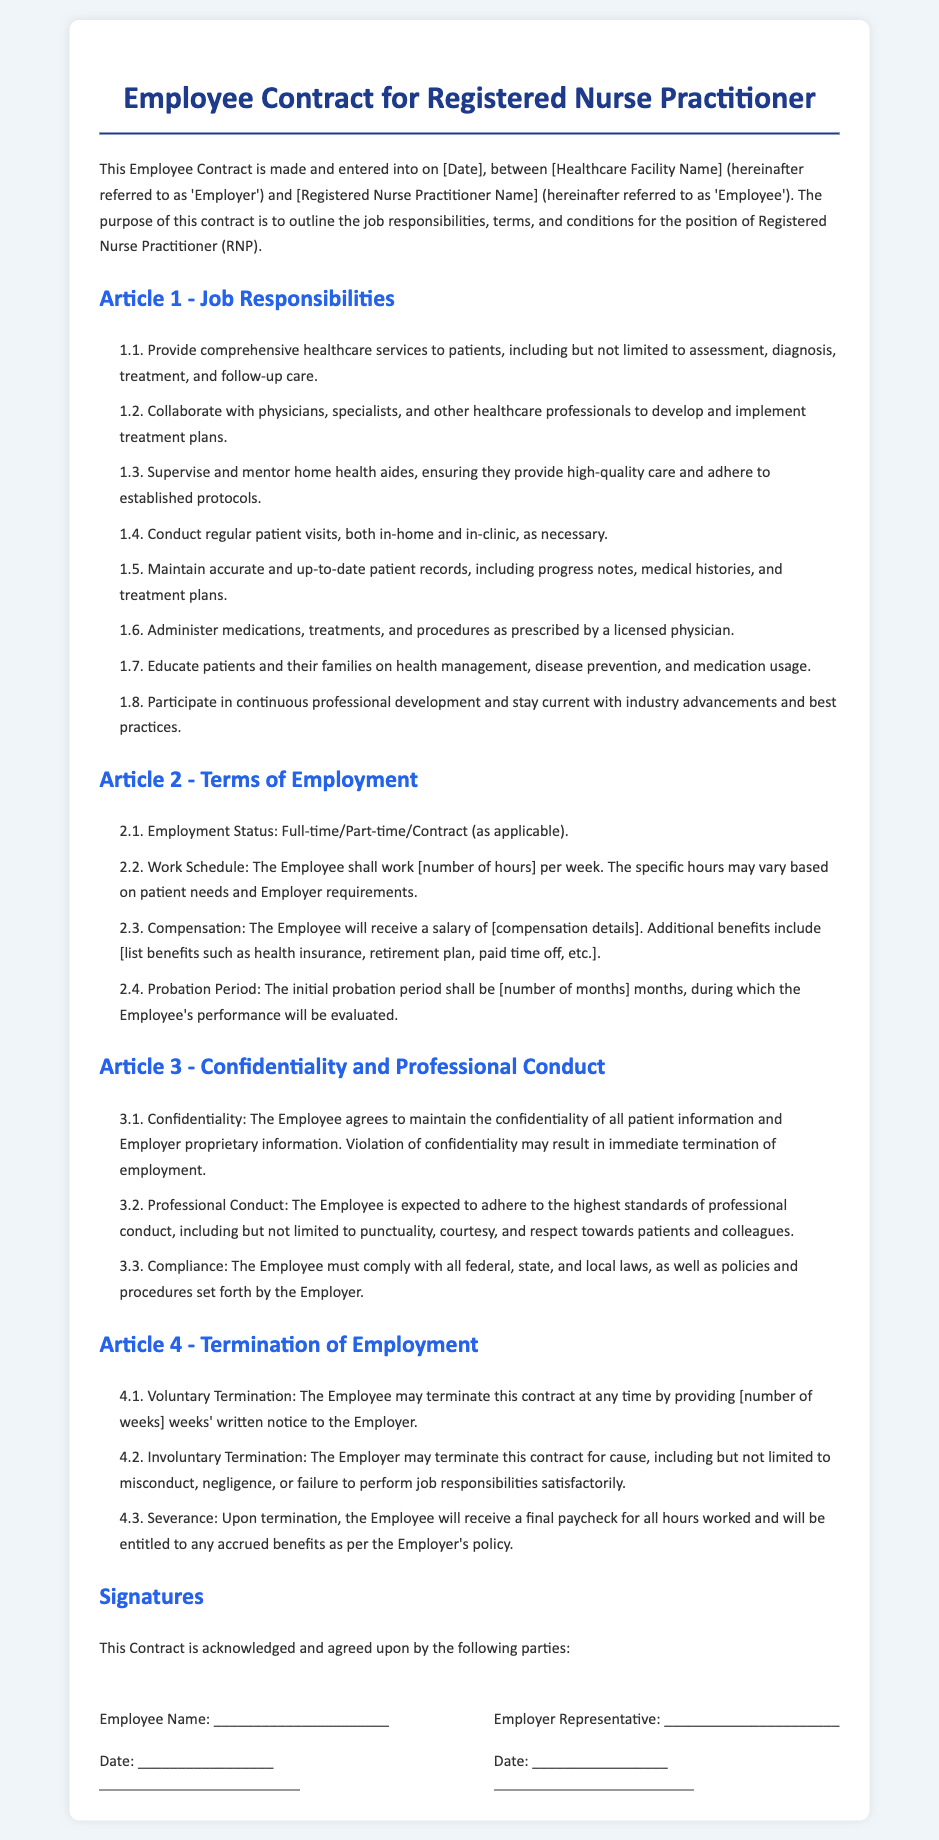What is the position title in the contract? The position title is explicitly mentioned in the document as "Registered Nurse Practitioner."
Answer: Registered Nurse Practitioner What is one of the job responsibilities of the Employee? The document lists various responsibilities, one of which is to "provide comprehensive healthcare services to patients."
Answer: Provide comprehensive healthcare services to patients How many months is the probation period? The document specifies the probation period but requires a number to be filled in; hence the answer should reflect that.
Answer: [number of months] What kind of employment status is mentioned? The document states the employment status could be "Full-time/Part-time/Contract."
Answer: Full-time/Part-time/Contract What is required for voluntary termination? The document indicates that the Employee may terminate the contract by providing a certain number of weeks' notice.
Answer: [number of weeks] What type of conduct is expected from the Employee? The contract highlights that the Employee is expected to adhere to the "highest standards of professional conduct."
Answer: Highest standards of professional conduct What should the Employee maintain regarding patient information? The document emphasizes the importance of confidentiality regarding patient information.
Answer: Confidentiality Who are the two parties involved in the contract? The document identifies the two parties as the "Employer" and the "Employee."
Answer: Employer and Employee 